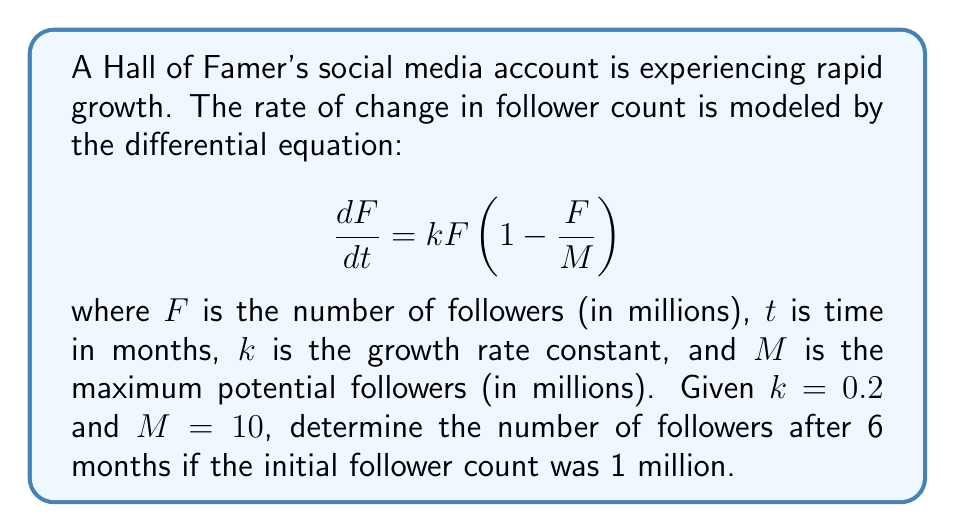Can you answer this question? To solve this problem, we need to use the logistic growth model, which is represented by the given differential equation. Let's approach this step-by-step:

1) The logistic equation has the general solution:

   $$F(t) = \frac{M}{1 + (\frac{M}{F_0} - 1)e^{-kt}}$$

   where $F_0$ is the initial number of followers.

2) We are given:
   - $k = 0.2$ (growth rate constant)
   - $M = 10$ million (maximum potential followers)
   - $F_0 = 1$ million (initial followers)
   - $t = 6$ months

3) Let's substitute these values into the solution:

   $$F(6) = \frac{10}{1 + (\frac{10}{1} - 1)e^{-0.2(6)}}$$

4) Simplify:
   $$F(6) = \frac{10}{1 + 9e^{-1.2}}$$

5) Calculate $e^{-1.2}$:
   $$e^{-1.2} \approx 0.301194$$

6) Substitute this value:
   $$F(6) = \frac{10}{1 + 9(0.301194)} = \frac{10}{3.710746}$$

7) Calculate the final result:
   $$F(6) \approx 2.695135$$

Therefore, after 6 months, the Hall of Famer's account will have approximately 2.695 million followers.
Answer: $F(6) \approx 2.695$ million followers 